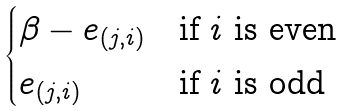Convert formula to latex. <formula><loc_0><loc_0><loc_500><loc_500>\begin{cases} \beta - e _ { ( j , i ) } & \text {if $i$ is even} \\ e _ { ( j , i ) } & \text {if $i$ is odd} \end{cases}</formula> 